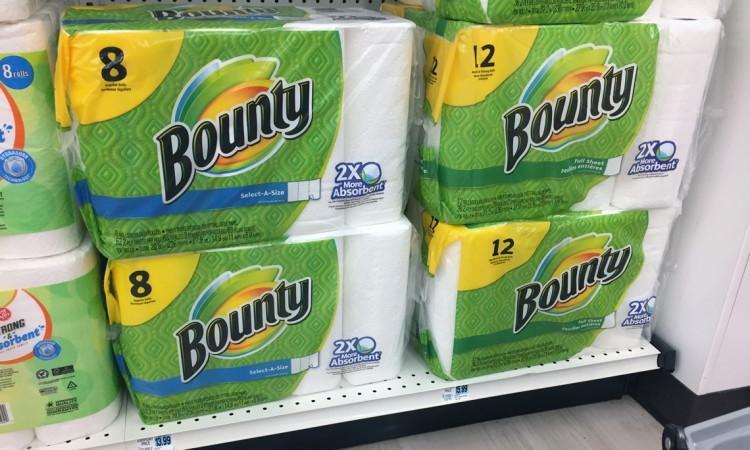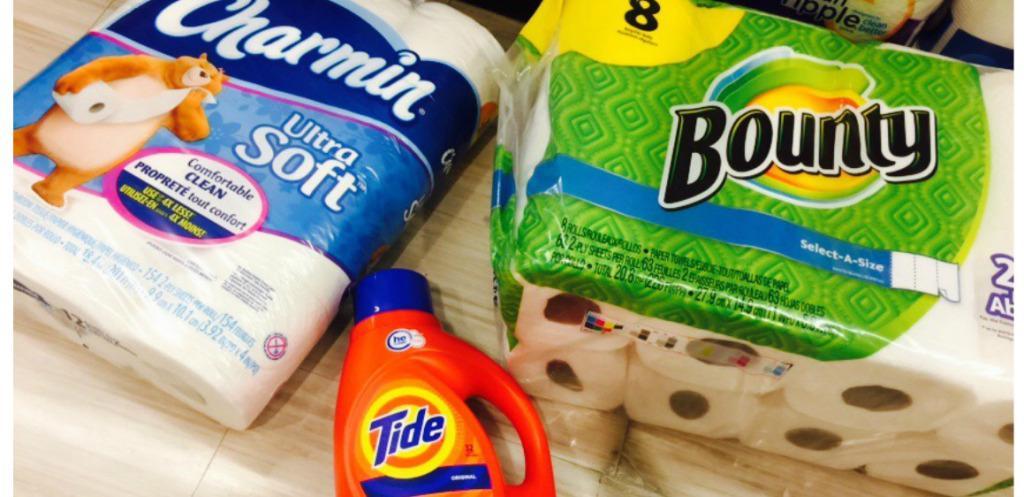The first image is the image on the left, the second image is the image on the right. For the images shown, is this caption "There are both Bounty and Scott brand paper towels." true? Answer yes or no. No. The first image is the image on the left, the second image is the image on the right. Considering the images on both sides, is "Each image shows multipack paper towels in green and yellow packaging on store shelves with white pegboard." valid? Answer yes or no. No. 